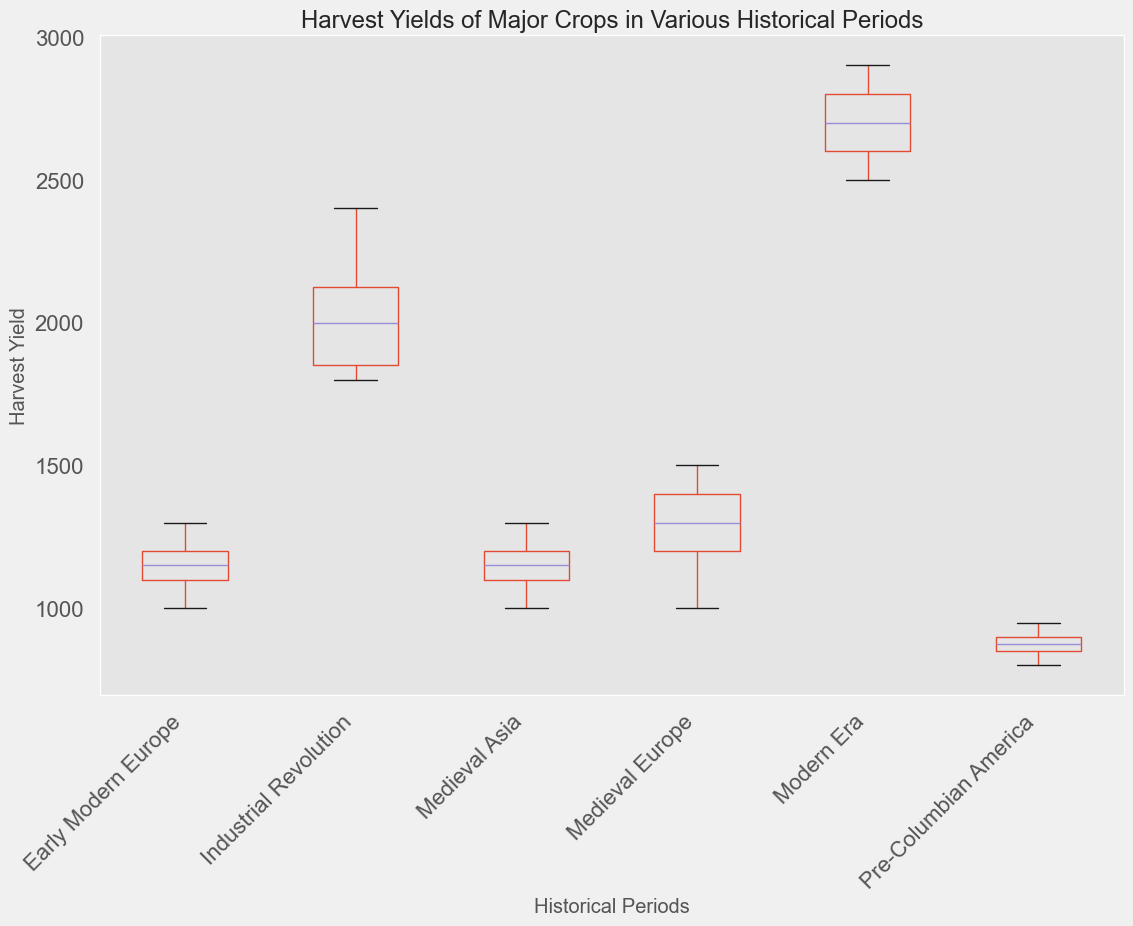What is the median harvest yield during the Modern Era? First, identify the group labeled 'Modern Era.' Then locate the median value of the box plot for this group.
Answer: The median value is around 2700 Which period has the highest median harvest yield for Wheat? Identify the categories corresponding to Wheat and observe the box plots. Compare the median lines to find the highest one.
Answer: The Modern Era How does the range of harvest yields in the Industrial Revolution compare to the range in Medieval Europe? Look at the box plots for both periods and compare the lengths of the boxes (which represent the interquartile range) plus the whiskers.
Answer: The Industrial Revolution has a wider range What is the interquartile range (IQR) of harvest yields for Rice in the Modern Era? Find the box plot for Rice in the Modern Era and measure the distance between the lower quartile (Q1) and the upper quartile (Q3).
Answer: Around 450 Which crop showed the most significant change in median harvest yield from the Industrial Revolution to the Modern Era? Compare the changes in median lines between the two periods for each crop. Note which crop has the largest distance between the medians.
Answer: Corn During which period did Potatoes have the smallest interquartile range? Compare the lengths of the boxes representing the IQR for Potatoes in different periods.
Answer: Early Modern Europe Which crop had the least variability in harvest yields during the Industrial Revolution? Identify the crop with the shortest distance between the lowest and highest whiskers in the Industrial Revolution.
Answer: Corn What is the difference between the maximum harvest yield for Rice in the Industrial Revolution and the Modern Era? Determine the highest point of the whiskers or outliers for Rice in both periods and subtract the former from the latter.
Answer: 1000 How did the harvest yield distribution for Corn in Pre-Columbian America compare to other periods? Examine the shape, IQR, and range of the box plot for Corn in Pre-Columbian America compared to other defined periods.
Answer: Smaller range, lower median Which period exhibited the highest variability in harvest yields for Wheat, and how is this observed? Compare the total range (distance between the lowest and highest whisker) for Wheat in each period. The period with the longest total range has the highest variability.
Answer: The Modern Era 